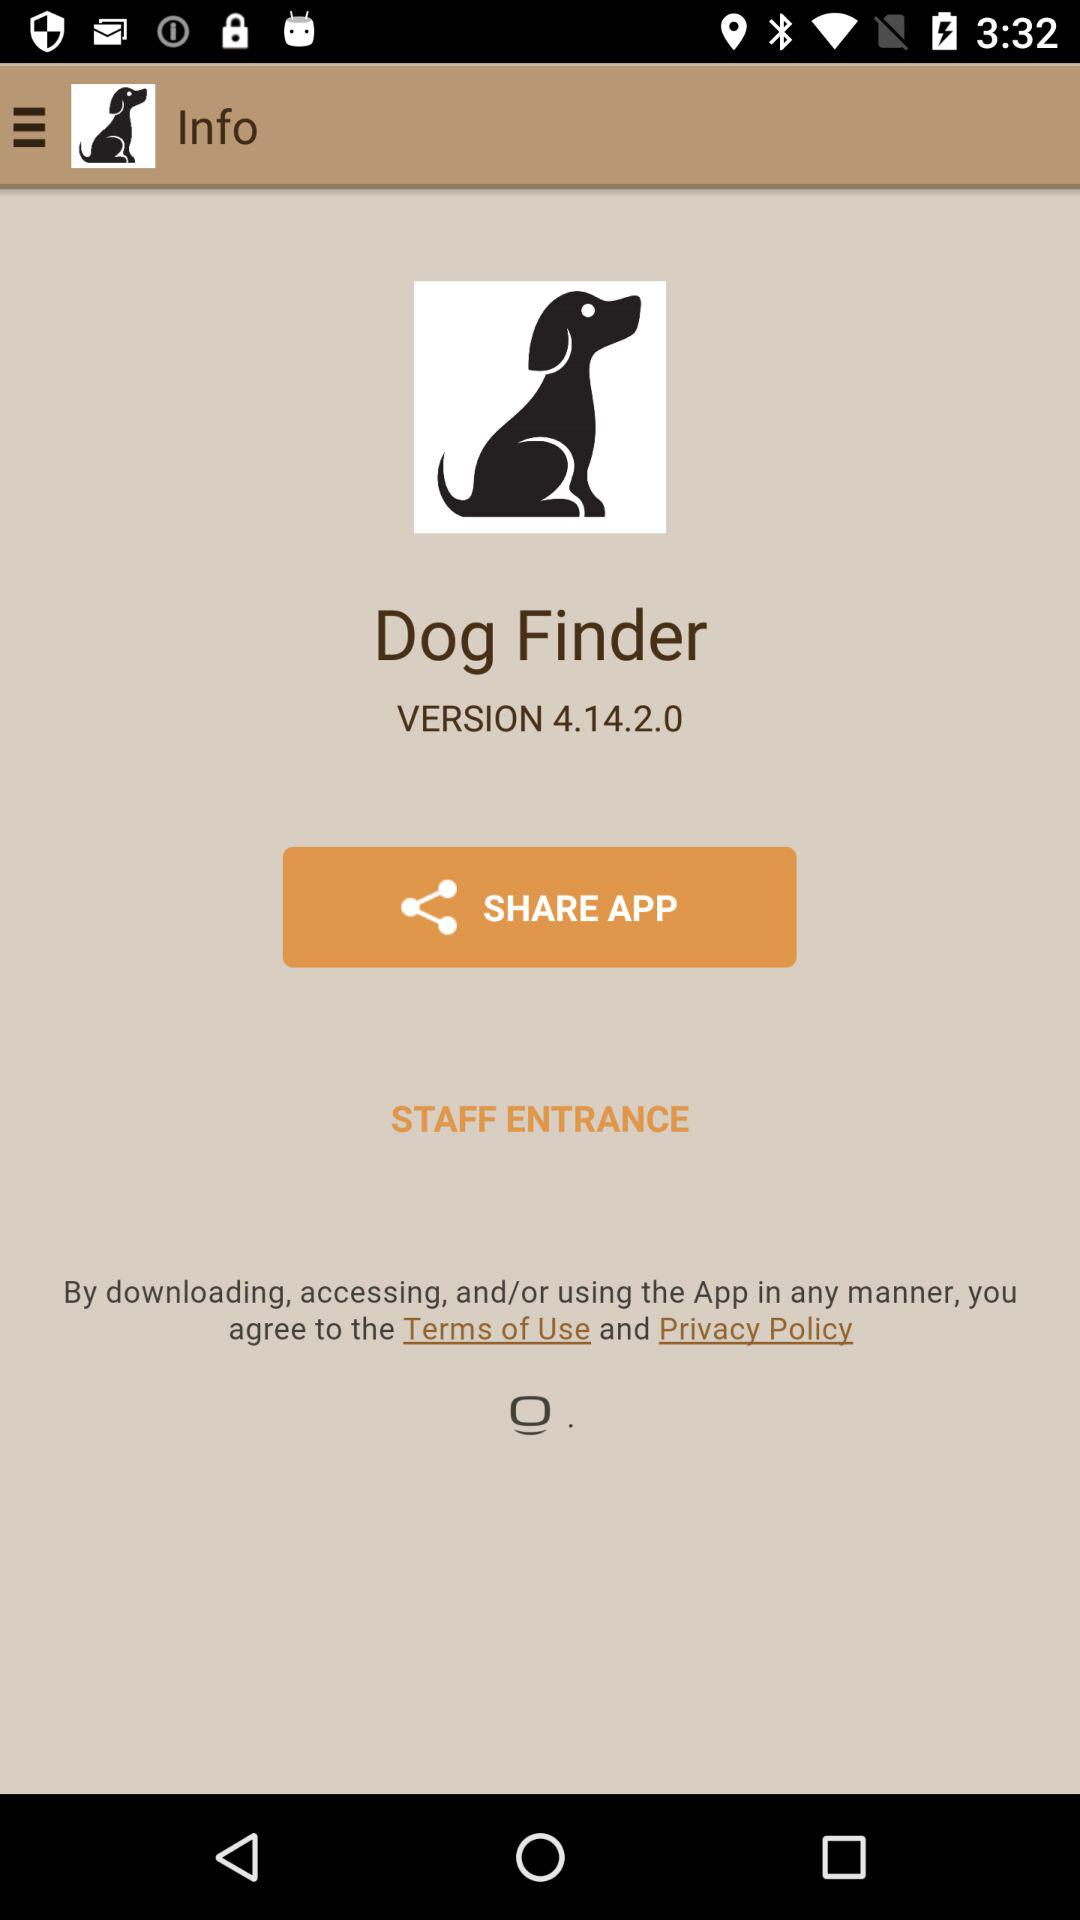What is the version of the application being used? The version of the application being used is 4.14.2.0. 